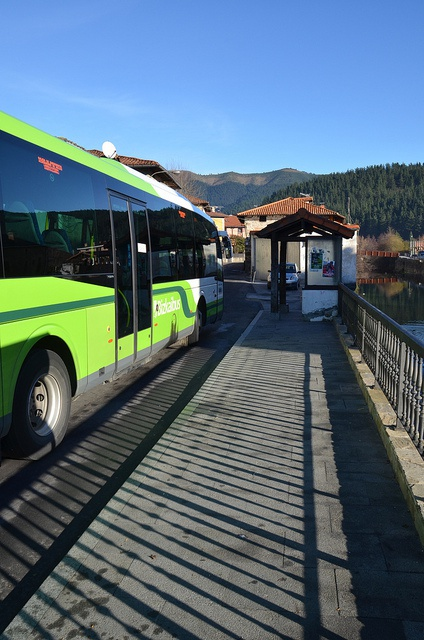Describe the objects in this image and their specific colors. I can see bus in lightblue, black, lightgreen, and blue tones and car in lightblue, black, gray, and navy tones in this image. 